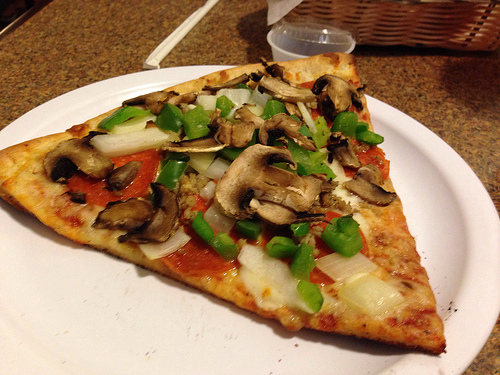Please provide the bounding box coordinate of the region this sentence describes: cooked mushroom on a pizza. The area containing cooked mushrooms on a pizza is defined by the coordinates [0.51, 0.34, 0.64, 0.44]. 